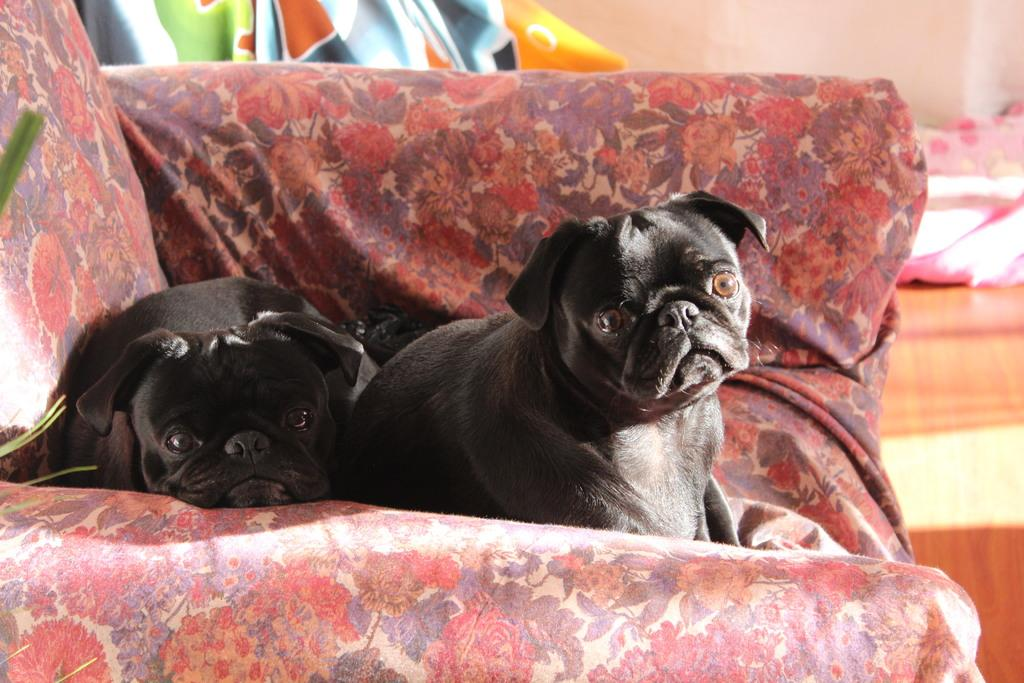What type of animals are present in the image? There are dogs in the image. Where are the dogs located? The dogs are on a sofa. What type of punishment is being administered to the dogs in the image? There is no punishment being administered to the dogs in the image; they are simply sitting on a sofa. What type of wax can be seen on the sofa in the image? There is no wax present on the sofa or in the image. 